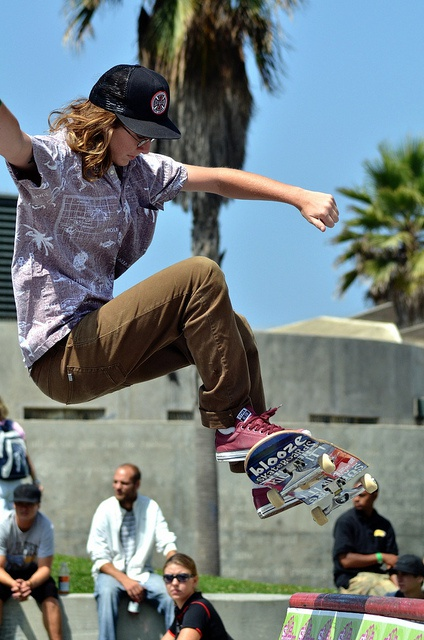Describe the objects in this image and their specific colors. I can see people in lightblue, black, gray, and maroon tones, skateboard in lightblue, darkgray, gray, black, and navy tones, people in lightblue, white, darkgray, and black tones, people in lightblue, black, gray, maroon, and brown tones, and people in lightblue, black, gray, darkgray, and khaki tones in this image. 